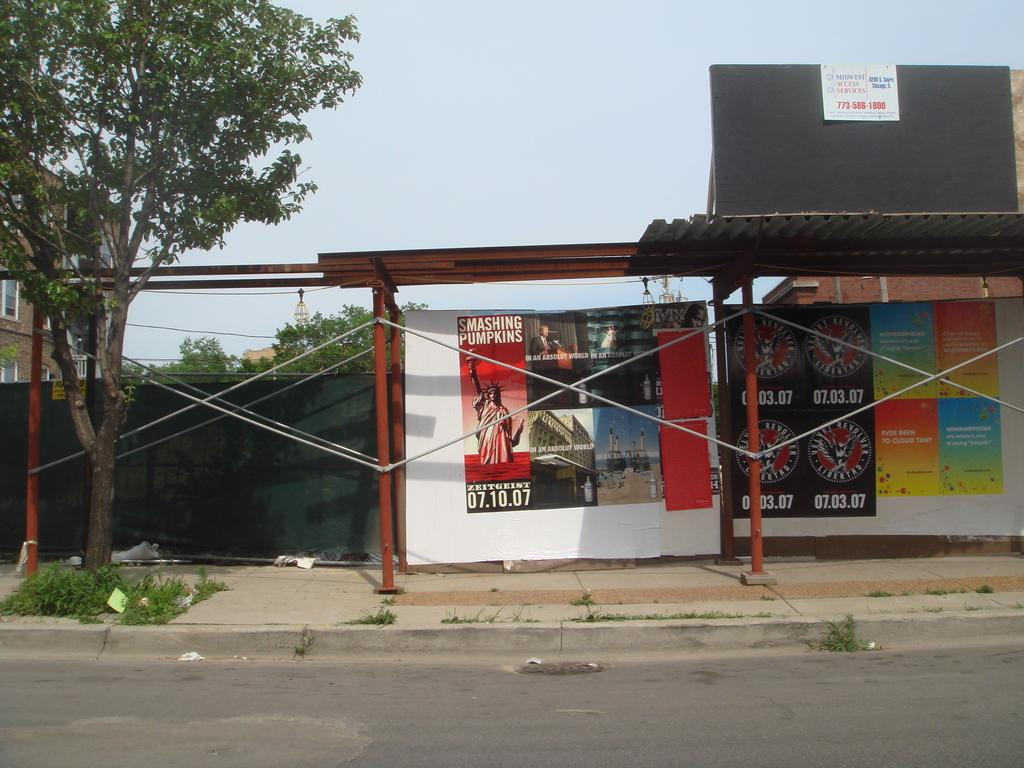What type of structure is visible in the image? There is an open shed in the image. What is located under the shed? There are hoardings under the shed. What can be seen on the left side of the image? There are trees and a building with windows on the left side of the image. Can you see a leg sticking out from under the shed in the image? There is no leg visible under the shed in the image. Is there a nest in one of the trees on the left side of the image? There is no nest visible in any of the trees on the left side of the image. 